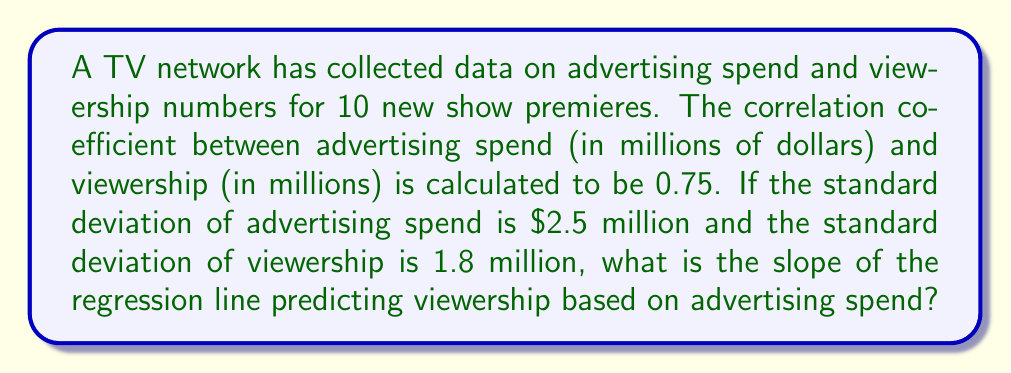Solve this math problem. To solve this problem, we'll use the formula for the slope of the regression line in terms of correlation coefficient and standard deviations:

1) The formula for the slope (b) of the regression line is:

   $$b = r \frac{s_y}{s_x}$$

   Where:
   $r$ is the correlation coefficient
   $s_y$ is the standard deviation of the dependent variable (viewership)
   $s_x$ is the standard deviation of the independent variable (advertising spend)

2) We're given:
   $r = 0.75$
   $s_x = 2.5$ million dollars
   $s_y = 1.8$ million viewers

3) Substituting these values into the formula:

   $$b = 0.75 \frac{1.8}{2.5}$$

4) Simplifying:

   $$b = 0.75 \times 0.72 = 0.54$$

5) Therefore, the slope of the regression line is 0.54 million viewers per million dollars spent on advertising.
Answer: 0.54 million viewers per million dollars 